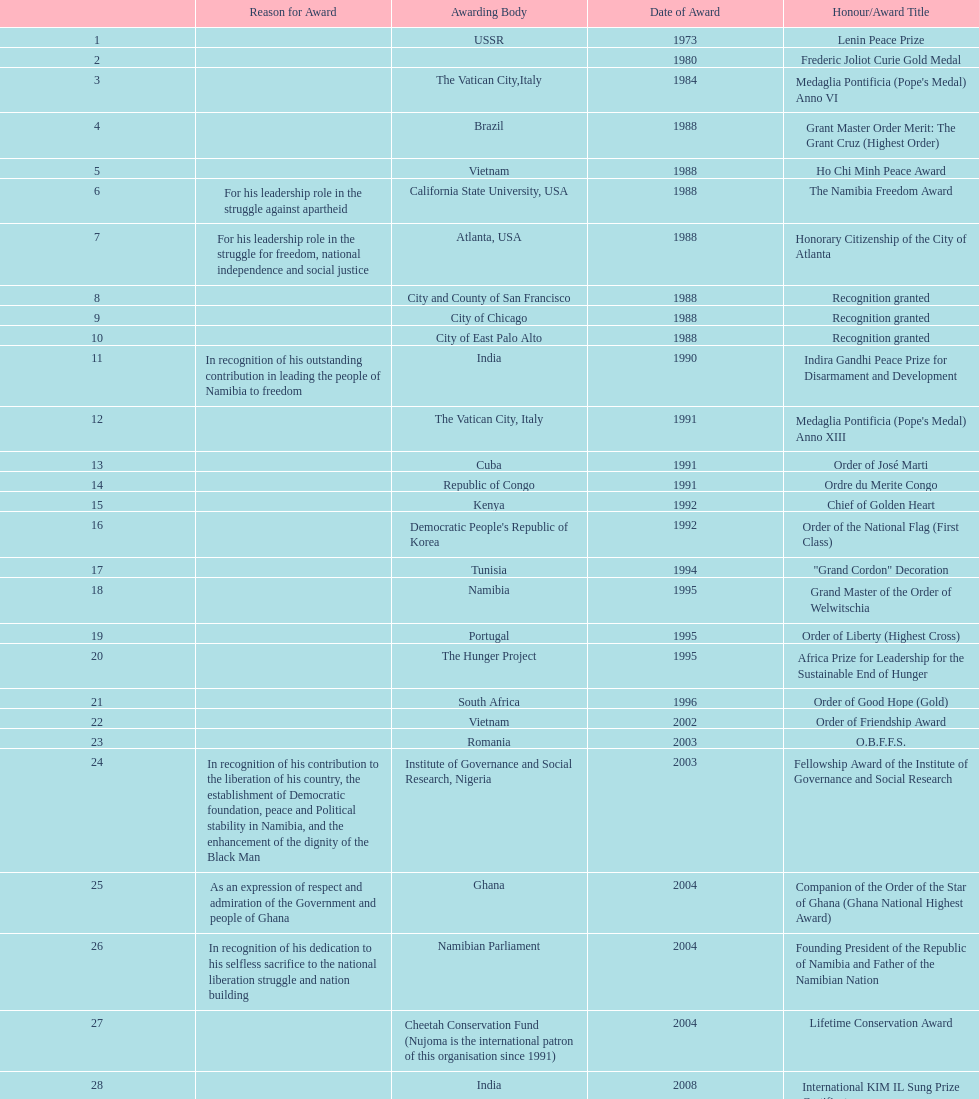What was the name of the honor/award title given after the international kim il sung prize certificate? Sir Seretse Khama SADC Meda. Could you parse the entire table? {'header': ['', 'Reason for Award', 'Awarding Body', 'Date of Award', 'Honour/Award Title'], 'rows': [['1', '', 'USSR', '1973', 'Lenin Peace Prize'], ['2', '', '', '1980', 'Frederic Joliot Curie Gold Medal'], ['3', '', 'The Vatican City,Italy', '1984', "Medaglia Pontificia (Pope's Medal) Anno VI"], ['4', '', 'Brazil', '1988', 'Grant Master Order Merit: The Grant Cruz (Highest Order)'], ['5', '', 'Vietnam', '1988', 'Ho Chi Minh Peace Award'], ['6', 'For his leadership role in the struggle against apartheid', 'California State University, USA', '1988', 'The Namibia Freedom Award'], ['7', 'For his leadership role in the struggle for freedom, national independence and social justice', 'Atlanta, USA', '1988', 'Honorary Citizenship of the City of Atlanta'], ['8', '', 'City and County of San Francisco', '1988', 'Recognition granted'], ['9', '', 'City of Chicago', '1988', 'Recognition granted'], ['10', '', 'City of East Palo Alto', '1988', 'Recognition granted'], ['11', 'In recognition of his outstanding contribution in leading the people of Namibia to freedom', 'India', '1990', 'Indira Gandhi Peace Prize for Disarmament and Development'], ['12', '', 'The Vatican City, Italy', '1991', "Medaglia Pontificia (Pope's Medal) Anno XIII"], ['13', '', 'Cuba', '1991', 'Order of José Marti'], ['14', '', 'Republic of Congo', '1991', 'Ordre du Merite Congo'], ['15', '', 'Kenya', '1992', 'Chief of Golden Heart'], ['16', '', "Democratic People's Republic of Korea", '1992', 'Order of the National Flag (First Class)'], ['17', '', 'Tunisia', '1994', '"Grand Cordon" Decoration'], ['18', '', 'Namibia', '1995', 'Grand Master of the Order of Welwitschia'], ['19', '', 'Portugal', '1995', 'Order of Liberty (Highest Cross)'], ['20', '', 'The Hunger Project', '1995', 'Africa Prize for Leadership for the Sustainable End of Hunger'], ['21', '', 'South Africa', '1996', 'Order of Good Hope (Gold)'], ['22', '', 'Vietnam', '2002', 'Order of Friendship Award'], ['23', '', 'Romania', '2003', 'O.B.F.F.S.'], ['24', 'In recognition of his contribution to the liberation of his country, the establishment of Democratic foundation, peace and Political stability in Namibia, and the enhancement of the dignity of the Black Man', 'Institute of Governance and Social Research, Nigeria', '2003', 'Fellowship Award of the Institute of Governance and Social Research'], ['25', 'As an expression of respect and admiration of the Government and people of Ghana', 'Ghana', '2004', 'Companion of the Order of the Star of Ghana (Ghana National Highest Award)'], ['26', 'In recognition of his dedication to his selfless sacrifice to the national liberation struggle and nation building', 'Namibian Parliament', '2004', 'Founding President of the Republic of Namibia and Father of the Namibian Nation'], ['27', '', 'Cheetah Conservation Fund (Nujoma is the international patron of this organisation since 1991)', '2004', 'Lifetime Conservation Award'], ['28', '', 'India', '2008', 'International KIM IL Sung Prize Certificate'], ['29', '', 'SADC', '2010', 'Sir Seretse Khama SADC Meda']]} 